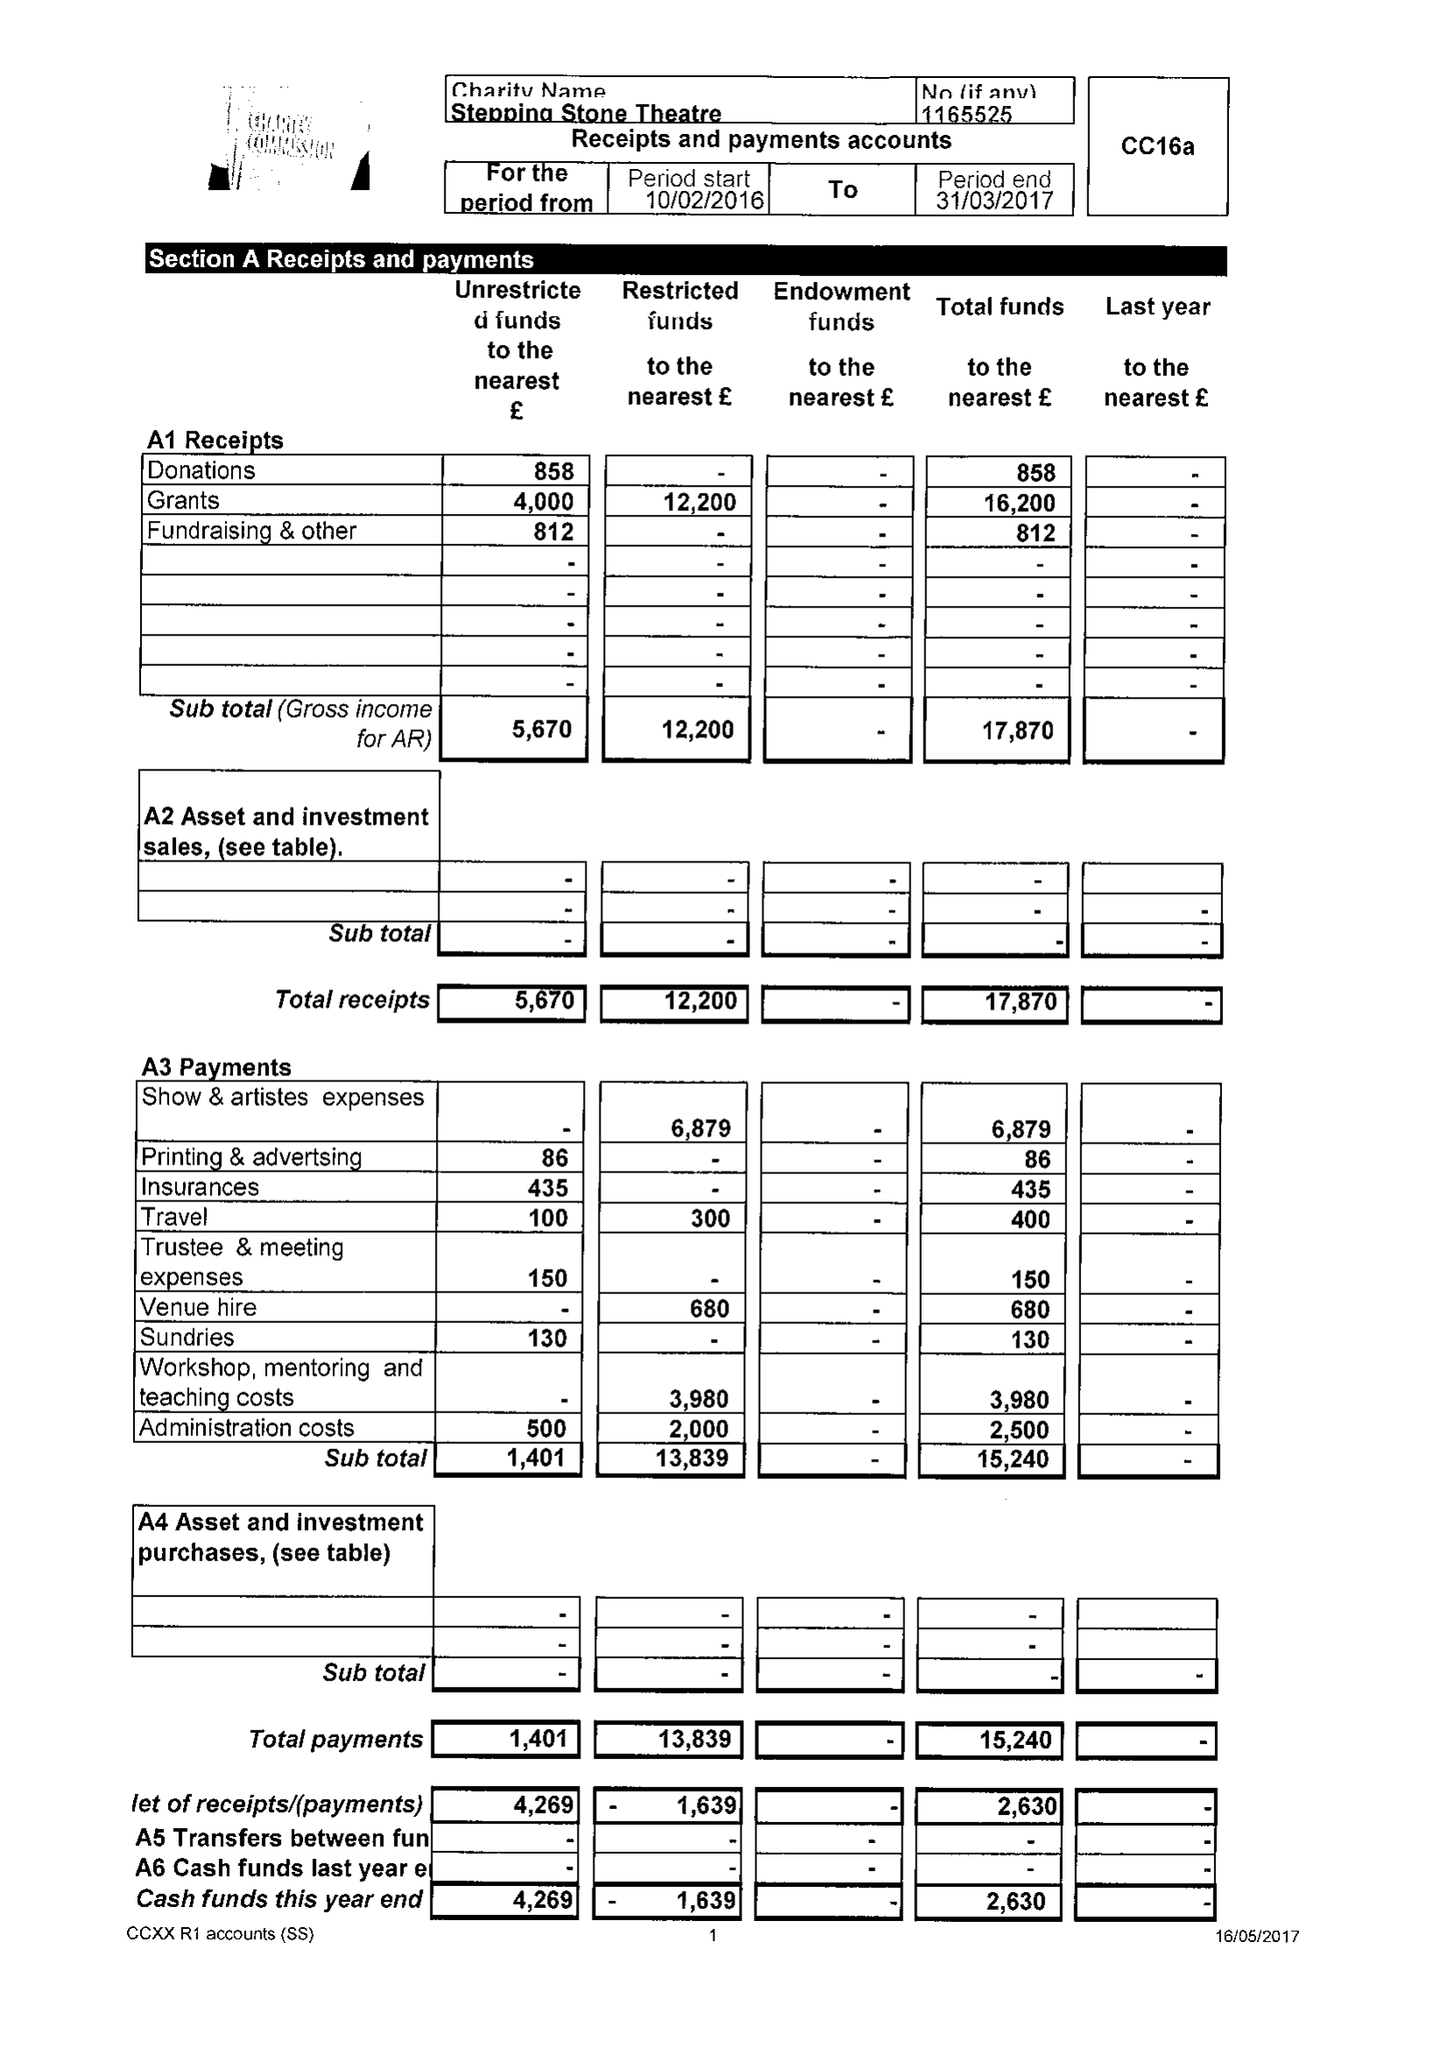What is the value for the income_annually_in_british_pounds?
Answer the question using a single word or phrase. 17870.00 